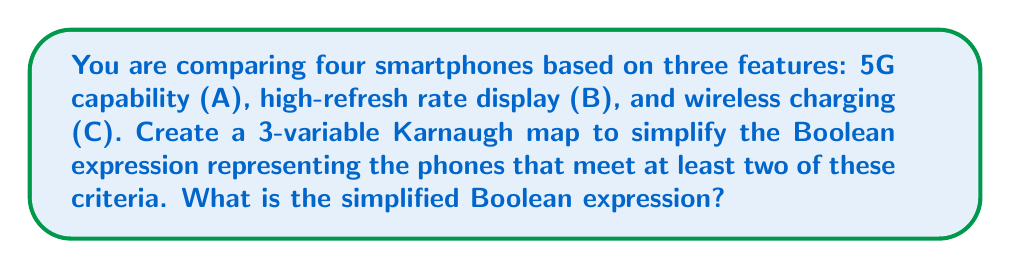Show me your answer to this math problem. Step 1: Create a truth table for the given conditions.
$$
\begin{array}{|c|c|c|c|}
\hline
A & B & C & F \\
\hline
0 & 0 & 0 & 0 \\
0 & 0 & 1 & 0 \\
0 & 1 & 0 & 0 \\
0 & 1 & 1 & 1 \\
1 & 0 & 0 & 0 \\
1 & 0 & 1 & 1 \\
1 & 1 & 0 & 1 \\
1 & 1 & 1 & 1 \\
\hline
\end{array}
$$

Step 2: Create a 3-variable Karnaugh map.
[asy]
unitsize(1cm);
defaultpen(fontsize(10pt));

for(int i=0; i<4; ++i) {
  for(int j=0; j<2; ++j) {
    draw((i,j)--(i+1,j)--(i+1,j+1)--(i,j+1)--cycle);
  }
}

label("00", (0.5,1.5));
label("01", (1.5,1.5));
label("11", (2.5,1.5));
label("10", (3.5,1.5));

label("0", (-0.5,0.5));
label("1", (-0.5,1.5));

label("AB", (-0.5,2.5));
label("C", (-1.5,1));

label("0", (0.5,0.5));
label("0", (1.5,0.5));
label("1", (2.5,0.5));
label("0", (3.5,0.5));

label("0", (0.5,1.5));
label("1", (1.5,1.5));
label("1", (2.5,1.5));
label("1", (3.5,1.5));
[/asy]

Step 3: Identify the largest possible groupings of 1's.
- Group 1: $AB$ (top right corner, 2 cells)
- Group 2: $AC$ (right column, 2 cells)
- Group 3: $BC$ (middle two cells of top row, 2 cells)

Step 4: Write the Boolean expression for each group.
- Group 1: $AB$
- Group 2: $AC$
- Group 3: $BC$

Step 5: Combine the expressions using OR operations.

The simplified Boolean expression is: $AB + AC + BC$
Answer: $AB + AC + BC$ 